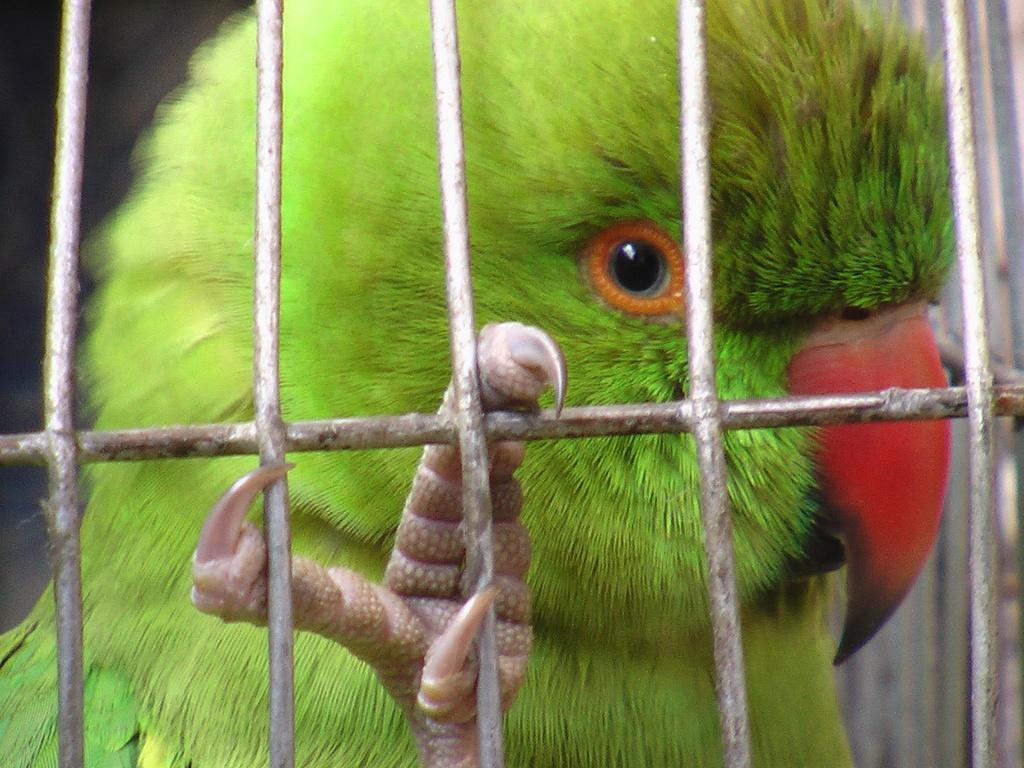What type of animal is in the image? There is a parrot in the image. Where is the parrot located? The parrot is inside a grill. What grade did the parrot receive for its performance in the organization's event? There is no mention of a grade, performance, or organization in the image, so it is not possible to answer this question. 